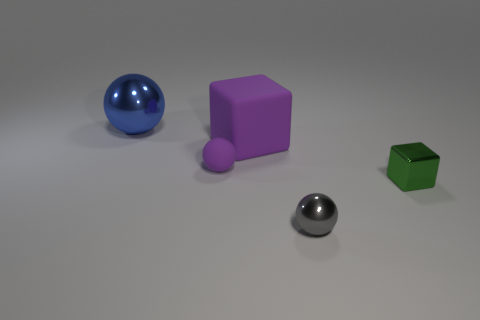What shape is the metallic thing behind the small shiny thing that is right of the metallic sphere to the right of the big blue object?
Provide a succinct answer. Sphere. Are there more big metal blocks than rubber things?
Your answer should be very brief. No. Is there a tiny blue thing?
Give a very brief answer. No. What number of objects are small metal objects in front of the small green block or metallic spheres that are in front of the tiny purple rubber ball?
Provide a short and direct response. 1. Is the color of the big cube the same as the big shiny sphere?
Your answer should be very brief. No. Is the number of tiny purple matte spheres less than the number of large yellow shiny blocks?
Your answer should be compact. No. There is a green block; are there any green blocks behind it?
Provide a short and direct response. No. Are the purple ball and the gray sphere made of the same material?
Provide a short and direct response. No. What color is the small metallic thing that is the same shape as the small purple rubber object?
Keep it short and to the point. Gray. There is a shiny sphere to the left of the small gray metal object; is it the same color as the metal block?
Offer a terse response. No. 